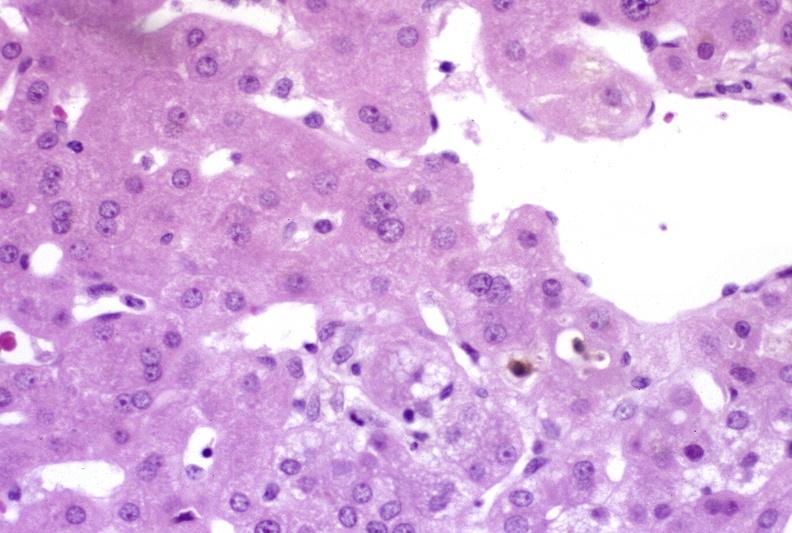what is present?
Answer the question using a single word or phrase. Liver 